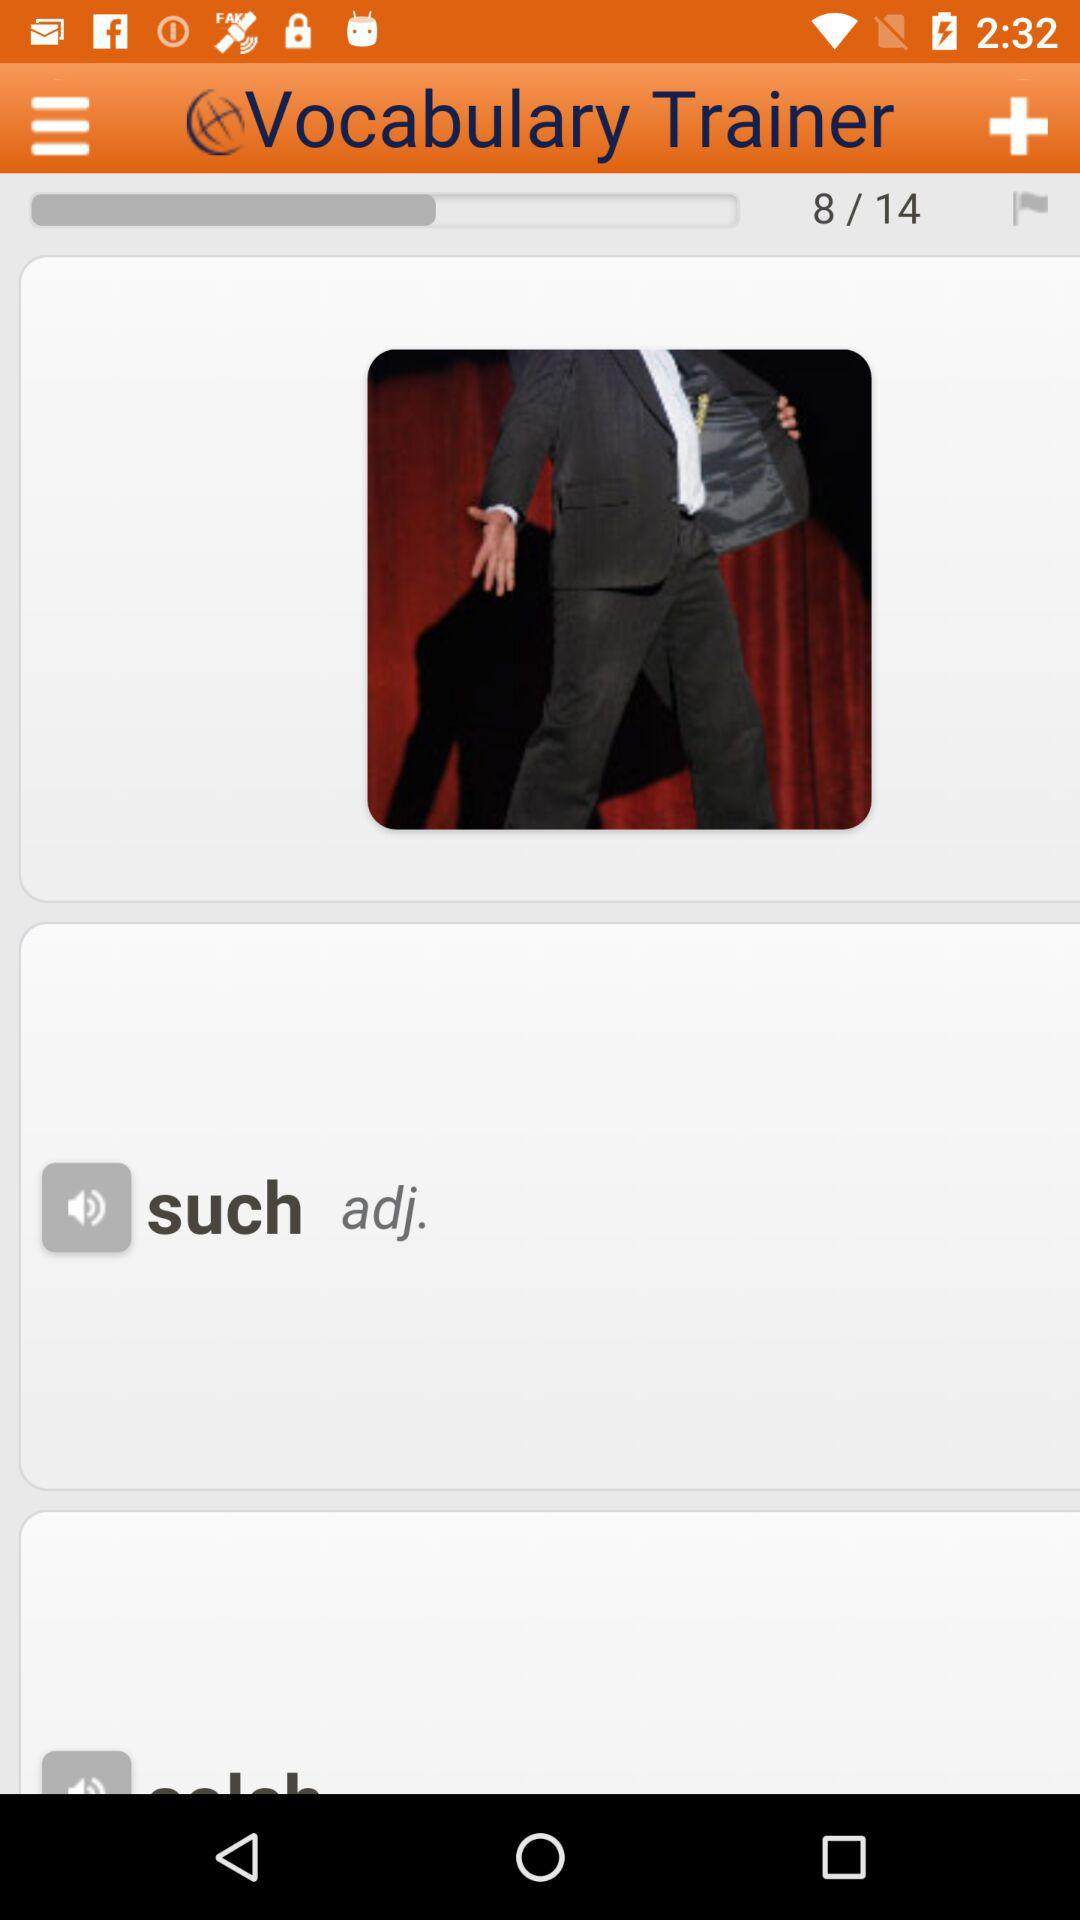Which word is an adjective? The word is "such". 